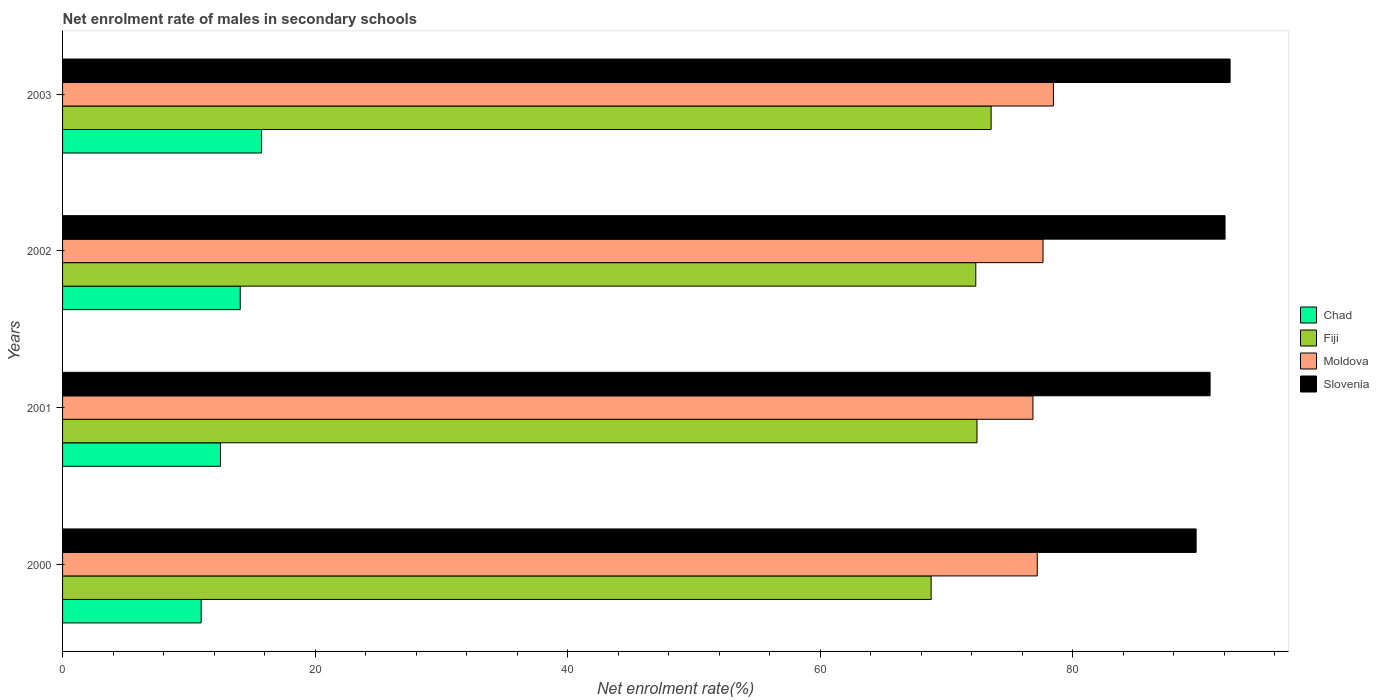How many groups of bars are there?
Offer a very short reply. 4. Are the number of bars on each tick of the Y-axis equal?
Make the answer very short. Yes. How many bars are there on the 4th tick from the bottom?
Provide a short and direct response. 4. In how many cases, is the number of bars for a given year not equal to the number of legend labels?
Your response must be concise. 0. What is the net enrolment rate of males in secondary schools in Fiji in 2002?
Your response must be concise. 72.32. Across all years, what is the maximum net enrolment rate of males in secondary schools in Moldova?
Your response must be concise. 78.47. Across all years, what is the minimum net enrolment rate of males in secondary schools in Chad?
Give a very brief answer. 10.98. In which year was the net enrolment rate of males in secondary schools in Chad minimum?
Your response must be concise. 2000. What is the total net enrolment rate of males in secondary schools in Fiji in the graph?
Your response must be concise. 287.06. What is the difference between the net enrolment rate of males in secondary schools in Moldova in 2001 and that in 2002?
Your answer should be very brief. -0.8. What is the difference between the net enrolment rate of males in secondary schools in Slovenia in 2001 and the net enrolment rate of males in secondary schools in Moldova in 2003?
Offer a very short reply. 12.41. What is the average net enrolment rate of males in secondary schools in Moldova per year?
Your answer should be compact. 77.54. In the year 2000, what is the difference between the net enrolment rate of males in secondary schools in Slovenia and net enrolment rate of males in secondary schools in Fiji?
Provide a short and direct response. 20.98. What is the ratio of the net enrolment rate of males in secondary schools in Chad in 2000 to that in 2002?
Keep it short and to the point. 0.78. Is the difference between the net enrolment rate of males in secondary schools in Slovenia in 2000 and 2002 greater than the difference between the net enrolment rate of males in secondary schools in Fiji in 2000 and 2002?
Give a very brief answer. Yes. What is the difference between the highest and the second highest net enrolment rate of males in secondary schools in Chad?
Provide a short and direct response. 1.68. What is the difference between the highest and the lowest net enrolment rate of males in secondary schools in Slovenia?
Your answer should be compact. 2.69. In how many years, is the net enrolment rate of males in secondary schools in Moldova greater than the average net enrolment rate of males in secondary schools in Moldova taken over all years?
Offer a very short reply. 2. What does the 4th bar from the top in 2001 represents?
Offer a terse response. Chad. What does the 1st bar from the bottom in 2003 represents?
Provide a short and direct response. Chad. Is it the case that in every year, the sum of the net enrolment rate of males in secondary schools in Chad and net enrolment rate of males in secondary schools in Moldova is greater than the net enrolment rate of males in secondary schools in Fiji?
Offer a terse response. Yes. How many years are there in the graph?
Offer a very short reply. 4. What is the difference between two consecutive major ticks on the X-axis?
Offer a very short reply. 20. Are the values on the major ticks of X-axis written in scientific E-notation?
Offer a very short reply. No. What is the title of the graph?
Give a very brief answer. Net enrolment rate of males in secondary schools. Does "Jordan" appear as one of the legend labels in the graph?
Make the answer very short. No. What is the label or title of the X-axis?
Your answer should be very brief. Net enrolment rate(%). What is the label or title of the Y-axis?
Your answer should be compact. Years. What is the Net enrolment rate(%) of Chad in 2000?
Your response must be concise. 10.98. What is the Net enrolment rate(%) in Fiji in 2000?
Provide a succinct answer. 68.79. What is the Net enrolment rate(%) in Moldova in 2000?
Make the answer very short. 77.19. What is the Net enrolment rate(%) in Slovenia in 2000?
Provide a short and direct response. 89.77. What is the Net enrolment rate(%) in Chad in 2001?
Give a very brief answer. 12.51. What is the Net enrolment rate(%) in Fiji in 2001?
Provide a short and direct response. 72.42. What is the Net enrolment rate(%) in Moldova in 2001?
Ensure brevity in your answer.  76.85. What is the Net enrolment rate(%) of Slovenia in 2001?
Keep it short and to the point. 90.88. What is the Net enrolment rate(%) in Chad in 2002?
Your answer should be very brief. 14.07. What is the Net enrolment rate(%) in Fiji in 2002?
Give a very brief answer. 72.32. What is the Net enrolment rate(%) in Moldova in 2002?
Your answer should be compact. 77.65. What is the Net enrolment rate(%) of Slovenia in 2002?
Provide a succinct answer. 92.06. What is the Net enrolment rate(%) in Chad in 2003?
Provide a succinct answer. 15.75. What is the Net enrolment rate(%) in Fiji in 2003?
Offer a very short reply. 73.54. What is the Net enrolment rate(%) of Moldova in 2003?
Your answer should be compact. 78.47. What is the Net enrolment rate(%) in Slovenia in 2003?
Your response must be concise. 92.46. Across all years, what is the maximum Net enrolment rate(%) of Chad?
Provide a short and direct response. 15.75. Across all years, what is the maximum Net enrolment rate(%) of Fiji?
Provide a succinct answer. 73.54. Across all years, what is the maximum Net enrolment rate(%) in Moldova?
Offer a terse response. 78.47. Across all years, what is the maximum Net enrolment rate(%) in Slovenia?
Keep it short and to the point. 92.46. Across all years, what is the minimum Net enrolment rate(%) in Chad?
Your response must be concise. 10.98. Across all years, what is the minimum Net enrolment rate(%) in Fiji?
Ensure brevity in your answer.  68.79. Across all years, what is the minimum Net enrolment rate(%) in Moldova?
Offer a terse response. 76.85. Across all years, what is the minimum Net enrolment rate(%) in Slovenia?
Ensure brevity in your answer.  89.77. What is the total Net enrolment rate(%) in Chad in the graph?
Your response must be concise. 53.3. What is the total Net enrolment rate(%) of Fiji in the graph?
Keep it short and to the point. 287.06. What is the total Net enrolment rate(%) in Moldova in the graph?
Keep it short and to the point. 310.15. What is the total Net enrolment rate(%) in Slovenia in the graph?
Make the answer very short. 365.17. What is the difference between the Net enrolment rate(%) of Chad in 2000 and that in 2001?
Provide a short and direct response. -1.53. What is the difference between the Net enrolment rate(%) in Fiji in 2000 and that in 2001?
Your answer should be compact. -3.63. What is the difference between the Net enrolment rate(%) in Moldova in 2000 and that in 2001?
Give a very brief answer. 0.34. What is the difference between the Net enrolment rate(%) of Slovenia in 2000 and that in 2001?
Make the answer very short. -1.11. What is the difference between the Net enrolment rate(%) in Chad in 2000 and that in 2002?
Provide a short and direct response. -3.09. What is the difference between the Net enrolment rate(%) in Fiji in 2000 and that in 2002?
Offer a very short reply. -3.54. What is the difference between the Net enrolment rate(%) in Moldova in 2000 and that in 2002?
Your answer should be very brief. -0.46. What is the difference between the Net enrolment rate(%) of Slovenia in 2000 and that in 2002?
Provide a short and direct response. -2.29. What is the difference between the Net enrolment rate(%) in Chad in 2000 and that in 2003?
Make the answer very short. -4.78. What is the difference between the Net enrolment rate(%) in Fiji in 2000 and that in 2003?
Offer a very short reply. -4.75. What is the difference between the Net enrolment rate(%) in Moldova in 2000 and that in 2003?
Keep it short and to the point. -1.28. What is the difference between the Net enrolment rate(%) in Slovenia in 2000 and that in 2003?
Make the answer very short. -2.69. What is the difference between the Net enrolment rate(%) in Chad in 2001 and that in 2002?
Provide a succinct answer. -1.56. What is the difference between the Net enrolment rate(%) of Fiji in 2001 and that in 2002?
Ensure brevity in your answer.  0.09. What is the difference between the Net enrolment rate(%) in Moldova in 2001 and that in 2002?
Offer a terse response. -0.8. What is the difference between the Net enrolment rate(%) of Slovenia in 2001 and that in 2002?
Make the answer very short. -1.18. What is the difference between the Net enrolment rate(%) in Chad in 2001 and that in 2003?
Give a very brief answer. -3.25. What is the difference between the Net enrolment rate(%) in Fiji in 2001 and that in 2003?
Your answer should be compact. -1.12. What is the difference between the Net enrolment rate(%) in Moldova in 2001 and that in 2003?
Provide a short and direct response. -1.62. What is the difference between the Net enrolment rate(%) in Slovenia in 2001 and that in 2003?
Your response must be concise. -1.59. What is the difference between the Net enrolment rate(%) in Chad in 2002 and that in 2003?
Give a very brief answer. -1.68. What is the difference between the Net enrolment rate(%) in Fiji in 2002 and that in 2003?
Give a very brief answer. -1.21. What is the difference between the Net enrolment rate(%) of Moldova in 2002 and that in 2003?
Provide a succinct answer. -0.82. What is the difference between the Net enrolment rate(%) of Slovenia in 2002 and that in 2003?
Provide a succinct answer. -0.4. What is the difference between the Net enrolment rate(%) in Chad in 2000 and the Net enrolment rate(%) in Fiji in 2001?
Provide a short and direct response. -61.44. What is the difference between the Net enrolment rate(%) in Chad in 2000 and the Net enrolment rate(%) in Moldova in 2001?
Keep it short and to the point. -65.87. What is the difference between the Net enrolment rate(%) in Chad in 2000 and the Net enrolment rate(%) in Slovenia in 2001?
Offer a very short reply. -79.9. What is the difference between the Net enrolment rate(%) in Fiji in 2000 and the Net enrolment rate(%) in Moldova in 2001?
Ensure brevity in your answer.  -8.06. What is the difference between the Net enrolment rate(%) of Fiji in 2000 and the Net enrolment rate(%) of Slovenia in 2001?
Provide a succinct answer. -22.09. What is the difference between the Net enrolment rate(%) in Moldova in 2000 and the Net enrolment rate(%) in Slovenia in 2001?
Provide a short and direct response. -13.69. What is the difference between the Net enrolment rate(%) of Chad in 2000 and the Net enrolment rate(%) of Fiji in 2002?
Make the answer very short. -61.35. What is the difference between the Net enrolment rate(%) of Chad in 2000 and the Net enrolment rate(%) of Moldova in 2002?
Ensure brevity in your answer.  -66.67. What is the difference between the Net enrolment rate(%) in Chad in 2000 and the Net enrolment rate(%) in Slovenia in 2002?
Make the answer very short. -81.09. What is the difference between the Net enrolment rate(%) in Fiji in 2000 and the Net enrolment rate(%) in Moldova in 2002?
Offer a very short reply. -8.86. What is the difference between the Net enrolment rate(%) of Fiji in 2000 and the Net enrolment rate(%) of Slovenia in 2002?
Make the answer very short. -23.28. What is the difference between the Net enrolment rate(%) of Moldova in 2000 and the Net enrolment rate(%) of Slovenia in 2002?
Your answer should be very brief. -14.87. What is the difference between the Net enrolment rate(%) of Chad in 2000 and the Net enrolment rate(%) of Fiji in 2003?
Ensure brevity in your answer.  -62.56. What is the difference between the Net enrolment rate(%) in Chad in 2000 and the Net enrolment rate(%) in Moldova in 2003?
Give a very brief answer. -67.49. What is the difference between the Net enrolment rate(%) of Chad in 2000 and the Net enrolment rate(%) of Slovenia in 2003?
Make the answer very short. -81.49. What is the difference between the Net enrolment rate(%) in Fiji in 2000 and the Net enrolment rate(%) in Moldova in 2003?
Keep it short and to the point. -9.68. What is the difference between the Net enrolment rate(%) of Fiji in 2000 and the Net enrolment rate(%) of Slovenia in 2003?
Keep it short and to the point. -23.68. What is the difference between the Net enrolment rate(%) of Moldova in 2000 and the Net enrolment rate(%) of Slovenia in 2003?
Provide a succinct answer. -15.27. What is the difference between the Net enrolment rate(%) of Chad in 2001 and the Net enrolment rate(%) of Fiji in 2002?
Keep it short and to the point. -59.81. What is the difference between the Net enrolment rate(%) of Chad in 2001 and the Net enrolment rate(%) of Moldova in 2002?
Make the answer very short. -65.14. What is the difference between the Net enrolment rate(%) of Chad in 2001 and the Net enrolment rate(%) of Slovenia in 2002?
Your answer should be very brief. -79.55. What is the difference between the Net enrolment rate(%) in Fiji in 2001 and the Net enrolment rate(%) in Moldova in 2002?
Make the answer very short. -5.23. What is the difference between the Net enrolment rate(%) of Fiji in 2001 and the Net enrolment rate(%) of Slovenia in 2002?
Provide a short and direct response. -19.64. What is the difference between the Net enrolment rate(%) of Moldova in 2001 and the Net enrolment rate(%) of Slovenia in 2002?
Your response must be concise. -15.21. What is the difference between the Net enrolment rate(%) of Chad in 2001 and the Net enrolment rate(%) of Fiji in 2003?
Ensure brevity in your answer.  -61.03. What is the difference between the Net enrolment rate(%) of Chad in 2001 and the Net enrolment rate(%) of Moldova in 2003?
Make the answer very short. -65.96. What is the difference between the Net enrolment rate(%) in Chad in 2001 and the Net enrolment rate(%) in Slovenia in 2003?
Provide a short and direct response. -79.96. What is the difference between the Net enrolment rate(%) of Fiji in 2001 and the Net enrolment rate(%) of Moldova in 2003?
Offer a terse response. -6.05. What is the difference between the Net enrolment rate(%) in Fiji in 2001 and the Net enrolment rate(%) in Slovenia in 2003?
Provide a short and direct response. -20.05. What is the difference between the Net enrolment rate(%) of Moldova in 2001 and the Net enrolment rate(%) of Slovenia in 2003?
Provide a succinct answer. -15.61. What is the difference between the Net enrolment rate(%) of Chad in 2002 and the Net enrolment rate(%) of Fiji in 2003?
Offer a very short reply. -59.47. What is the difference between the Net enrolment rate(%) in Chad in 2002 and the Net enrolment rate(%) in Moldova in 2003?
Make the answer very short. -64.4. What is the difference between the Net enrolment rate(%) in Chad in 2002 and the Net enrolment rate(%) in Slovenia in 2003?
Your response must be concise. -78.39. What is the difference between the Net enrolment rate(%) in Fiji in 2002 and the Net enrolment rate(%) in Moldova in 2003?
Offer a terse response. -6.15. What is the difference between the Net enrolment rate(%) of Fiji in 2002 and the Net enrolment rate(%) of Slovenia in 2003?
Your answer should be compact. -20.14. What is the difference between the Net enrolment rate(%) of Moldova in 2002 and the Net enrolment rate(%) of Slovenia in 2003?
Give a very brief answer. -14.82. What is the average Net enrolment rate(%) in Chad per year?
Your response must be concise. 13.33. What is the average Net enrolment rate(%) of Fiji per year?
Your response must be concise. 71.76. What is the average Net enrolment rate(%) in Moldova per year?
Ensure brevity in your answer.  77.54. What is the average Net enrolment rate(%) of Slovenia per year?
Offer a very short reply. 91.29. In the year 2000, what is the difference between the Net enrolment rate(%) in Chad and Net enrolment rate(%) in Fiji?
Ensure brevity in your answer.  -57.81. In the year 2000, what is the difference between the Net enrolment rate(%) of Chad and Net enrolment rate(%) of Moldova?
Provide a succinct answer. -66.21. In the year 2000, what is the difference between the Net enrolment rate(%) in Chad and Net enrolment rate(%) in Slovenia?
Provide a succinct answer. -78.8. In the year 2000, what is the difference between the Net enrolment rate(%) in Fiji and Net enrolment rate(%) in Moldova?
Your answer should be very brief. -8.4. In the year 2000, what is the difference between the Net enrolment rate(%) in Fiji and Net enrolment rate(%) in Slovenia?
Make the answer very short. -20.98. In the year 2000, what is the difference between the Net enrolment rate(%) of Moldova and Net enrolment rate(%) of Slovenia?
Give a very brief answer. -12.58. In the year 2001, what is the difference between the Net enrolment rate(%) in Chad and Net enrolment rate(%) in Fiji?
Offer a terse response. -59.91. In the year 2001, what is the difference between the Net enrolment rate(%) of Chad and Net enrolment rate(%) of Moldova?
Keep it short and to the point. -64.34. In the year 2001, what is the difference between the Net enrolment rate(%) in Chad and Net enrolment rate(%) in Slovenia?
Make the answer very short. -78.37. In the year 2001, what is the difference between the Net enrolment rate(%) of Fiji and Net enrolment rate(%) of Moldova?
Keep it short and to the point. -4.43. In the year 2001, what is the difference between the Net enrolment rate(%) in Fiji and Net enrolment rate(%) in Slovenia?
Provide a short and direct response. -18.46. In the year 2001, what is the difference between the Net enrolment rate(%) of Moldova and Net enrolment rate(%) of Slovenia?
Offer a terse response. -14.03. In the year 2002, what is the difference between the Net enrolment rate(%) in Chad and Net enrolment rate(%) in Fiji?
Keep it short and to the point. -58.25. In the year 2002, what is the difference between the Net enrolment rate(%) in Chad and Net enrolment rate(%) in Moldova?
Keep it short and to the point. -63.58. In the year 2002, what is the difference between the Net enrolment rate(%) of Chad and Net enrolment rate(%) of Slovenia?
Offer a very short reply. -77.99. In the year 2002, what is the difference between the Net enrolment rate(%) in Fiji and Net enrolment rate(%) in Moldova?
Provide a short and direct response. -5.32. In the year 2002, what is the difference between the Net enrolment rate(%) of Fiji and Net enrolment rate(%) of Slovenia?
Your response must be concise. -19.74. In the year 2002, what is the difference between the Net enrolment rate(%) in Moldova and Net enrolment rate(%) in Slovenia?
Your answer should be very brief. -14.42. In the year 2003, what is the difference between the Net enrolment rate(%) in Chad and Net enrolment rate(%) in Fiji?
Your answer should be very brief. -57.78. In the year 2003, what is the difference between the Net enrolment rate(%) in Chad and Net enrolment rate(%) in Moldova?
Offer a terse response. -62.72. In the year 2003, what is the difference between the Net enrolment rate(%) of Chad and Net enrolment rate(%) of Slovenia?
Offer a very short reply. -76.71. In the year 2003, what is the difference between the Net enrolment rate(%) of Fiji and Net enrolment rate(%) of Moldova?
Give a very brief answer. -4.93. In the year 2003, what is the difference between the Net enrolment rate(%) in Fiji and Net enrolment rate(%) in Slovenia?
Your answer should be compact. -18.93. In the year 2003, what is the difference between the Net enrolment rate(%) in Moldova and Net enrolment rate(%) in Slovenia?
Provide a succinct answer. -13.99. What is the ratio of the Net enrolment rate(%) in Chad in 2000 to that in 2001?
Your answer should be compact. 0.88. What is the ratio of the Net enrolment rate(%) of Fiji in 2000 to that in 2001?
Give a very brief answer. 0.95. What is the ratio of the Net enrolment rate(%) of Moldova in 2000 to that in 2001?
Your answer should be very brief. 1. What is the ratio of the Net enrolment rate(%) in Slovenia in 2000 to that in 2001?
Provide a short and direct response. 0.99. What is the ratio of the Net enrolment rate(%) in Chad in 2000 to that in 2002?
Ensure brevity in your answer.  0.78. What is the ratio of the Net enrolment rate(%) in Fiji in 2000 to that in 2002?
Your response must be concise. 0.95. What is the ratio of the Net enrolment rate(%) of Moldova in 2000 to that in 2002?
Ensure brevity in your answer.  0.99. What is the ratio of the Net enrolment rate(%) of Slovenia in 2000 to that in 2002?
Ensure brevity in your answer.  0.98. What is the ratio of the Net enrolment rate(%) of Chad in 2000 to that in 2003?
Offer a terse response. 0.7. What is the ratio of the Net enrolment rate(%) in Fiji in 2000 to that in 2003?
Ensure brevity in your answer.  0.94. What is the ratio of the Net enrolment rate(%) in Moldova in 2000 to that in 2003?
Provide a succinct answer. 0.98. What is the ratio of the Net enrolment rate(%) in Slovenia in 2000 to that in 2003?
Provide a succinct answer. 0.97. What is the ratio of the Net enrolment rate(%) of Fiji in 2001 to that in 2002?
Keep it short and to the point. 1. What is the ratio of the Net enrolment rate(%) of Slovenia in 2001 to that in 2002?
Offer a terse response. 0.99. What is the ratio of the Net enrolment rate(%) in Chad in 2001 to that in 2003?
Your answer should be very brief. 0.79. What is the ratio of the Net enrolment rate(%) in Fiji in 2001 to that in 2003?
Offer a terse response. 0.98. What is the ratio of the Net enrolment rate(%) of Moldova in 2001 to that in 2003?
Make the answer very short. 0.98. What is the ratio of the Net enrolment rate(%) in Slovenia in 2001 to that in 2003?
Make the answer very short. 0.98. What is the ratio of the Net enrolment rate(%) of Chad in 2002 to that in 2003?
Make the answer very short. 0.89. What is the ratio of the Net enrolment rate(%) in Fiji in 2002 to that in 2003?
Your response must be concise. 0.98. What is the ratio of the Net enrolment rate(%) of Slovenia in 2002 to that in 2003?
Your response must be concise. 1. What is the difference between the highest and the second highest Net enrolment rate(%) in Chad?
Give a very brief answer. 1.68. What is the difference between the highest and the second highest Net enrolment rate(%) of Fiji?
Offer a terse response. 1.12. What is the difference between the highest and the second highest Net enrolment rate(%) of Moldova?
Ensure brevity in your answer.  0.82. What is the difference between the highest and the second highest Net enrolment rate(%) in Slovenia?
Ensure brevity in your answer.  0.4. What is the difference between the highest and the lowest Net enrolment rate(%) of Chad?
Provide a succinct answer. 4.78. What is the difference between the highest and the lowest Net enrolment rate(%) in Fiji?
Ensure brevity in your answer.  4.75. What is the difference between the highest and the lowest Net enrolment rate(%) of Moldova?
Ensure brevity in your answer.  1.62. What is the difference between the highest and the lowest Net enrolment rate(%) of Slovenia?
Give a very brief answer. 2.69. 